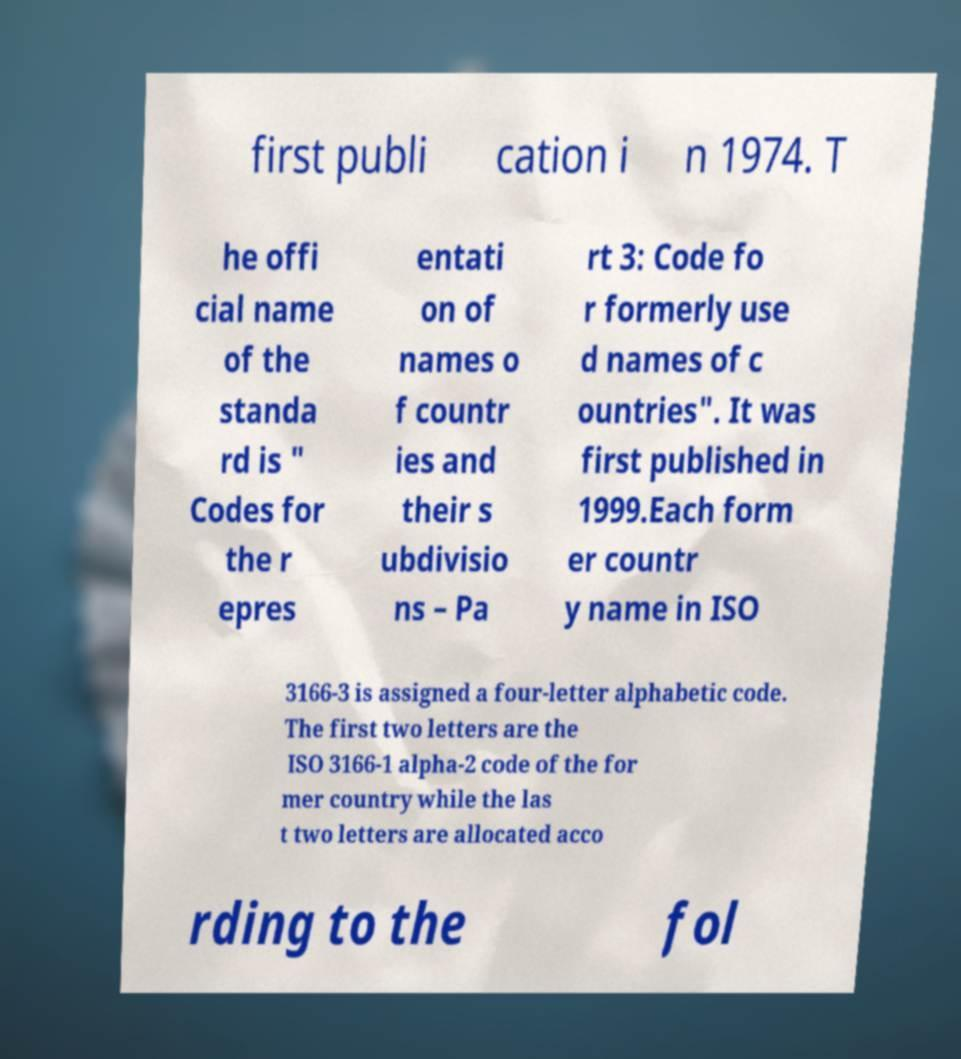I need the written content from this picture converted into text. Can you do that? first publi cation i n 1974. T he offi cial name of the standa rd is " Codes for the r epres entati on of names o f countr ies and their s ubdivisio ns – Pa rt 3: Code fo r formerly use d names of c ountries". It was first published in 1999.Each form er countr y name in ISO 3166-3 is assigned a four-letter alphabetic code. The first two letters are the ISO 3166-1 alpha-2 code of the for mer country while the las t two letters are allocated acco rding to the fol 